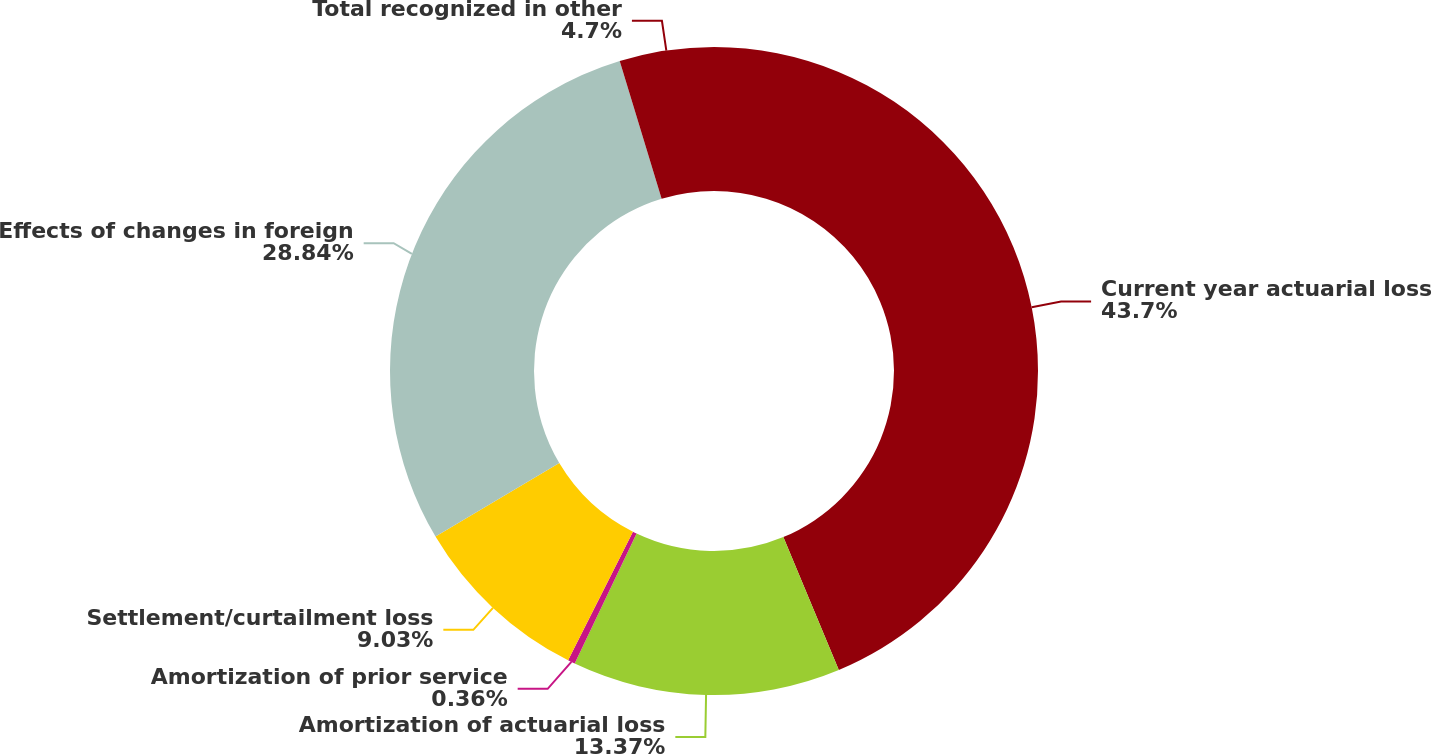<chart> <loc_0><loc_0><loc_500><loc_500><pie_chart><fcel>Current year actuarial loss<fcel>Amortization of actuarial loss<fcel>Amortization of prior service<fcel>Settlement/curtailment loss<fcel>Effects of changes in foreign<fcel>Total recognized in other<nl><fcel>43.71%<fcel>13.37%<fcel>0.36%<fcel>9.03%<fcel>28.84%<fcel>4.7%<nl></chart> 